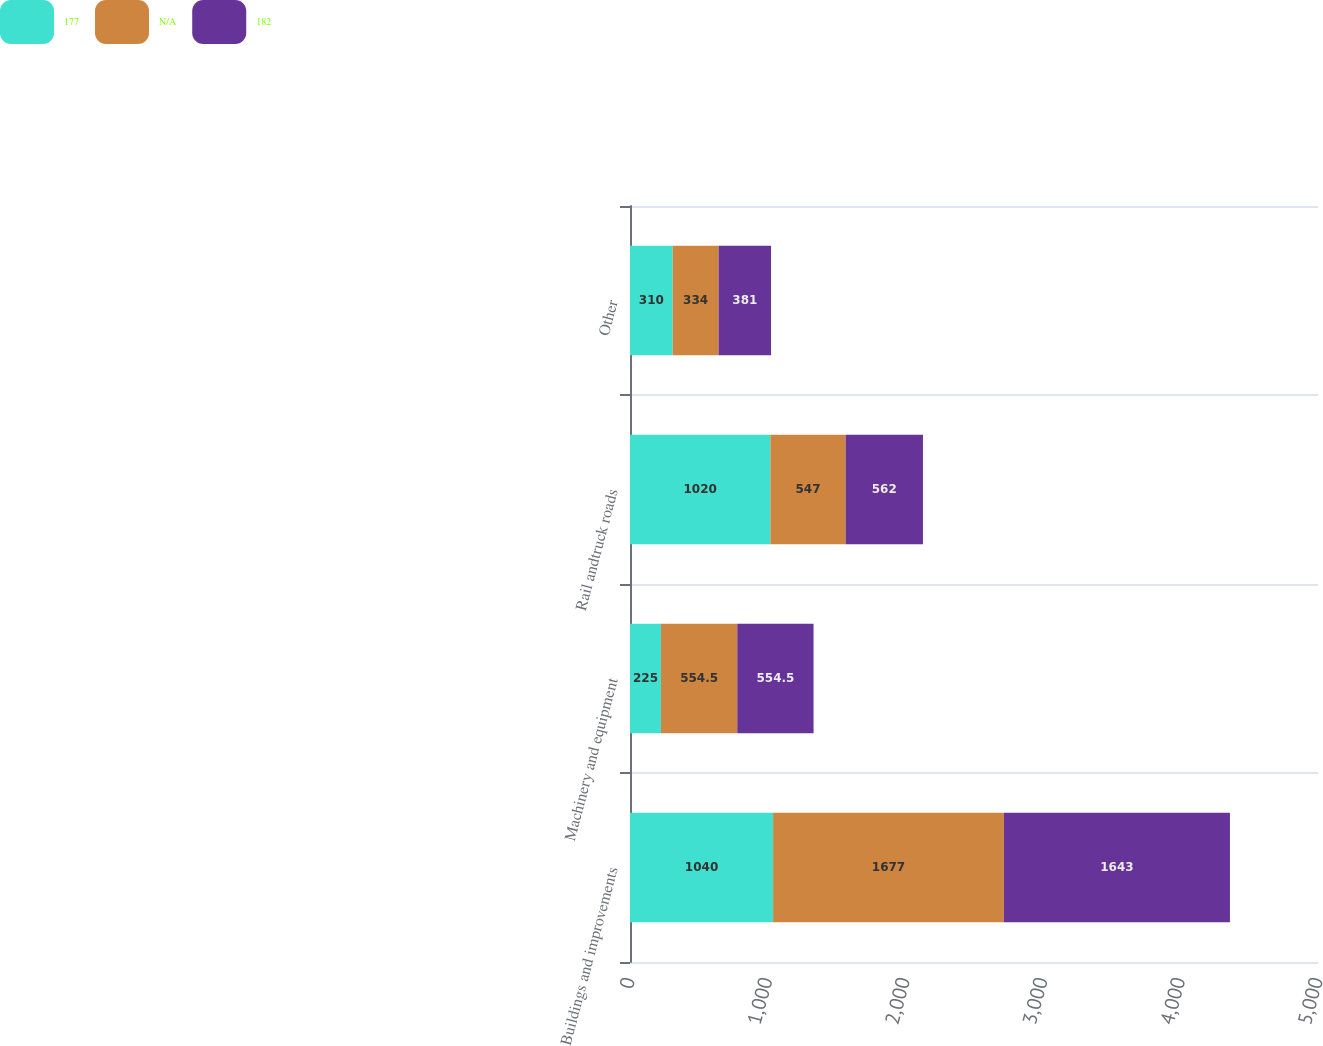<chart> <loc_0><loc_0><loc_500><loc_500><stacked_bar_chart><ecel><fcel>Buildings and improvements<fcel>Machinery and equipment<fcel>Rail andtruck roads<fcel>Other<nl><fcel>177<fcel>1040<fcel>225<fcel>1020<fcel>310<nl><fcel>nan<fcel>1677<fcel>554.5<fcel>547<fcel>334<nl><fcel>182<fcel>1643<fcel>554.5<fcel>562<fcel>381<nl></chart> 